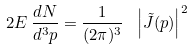<formula> <loc_0><loc_0><loc_500><loc_500>2 E \, \frac { d N } { d ^ { 3 } p } = \frac { 1 } { ( 2 \pi ) ^ { 3 } } \ \left | \tilde { J } ( p ) \right | ^ { 2 }</formula> 